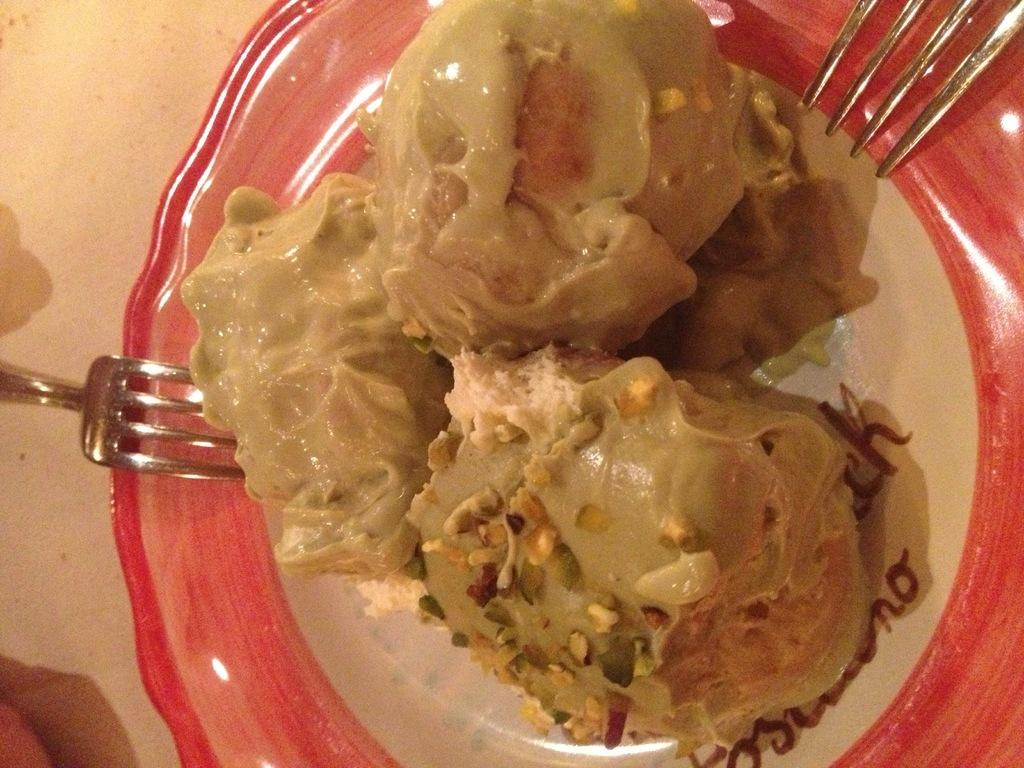What is the main object in the center of the image? There is a table in the center of the image. What utensils are present on the table? There are forks on the table. What type of food is on the plate on the table? There is a plate containing dessert on the table. What type of gun is depicted in the caption of the image? There is no gun or caption present in the image. 